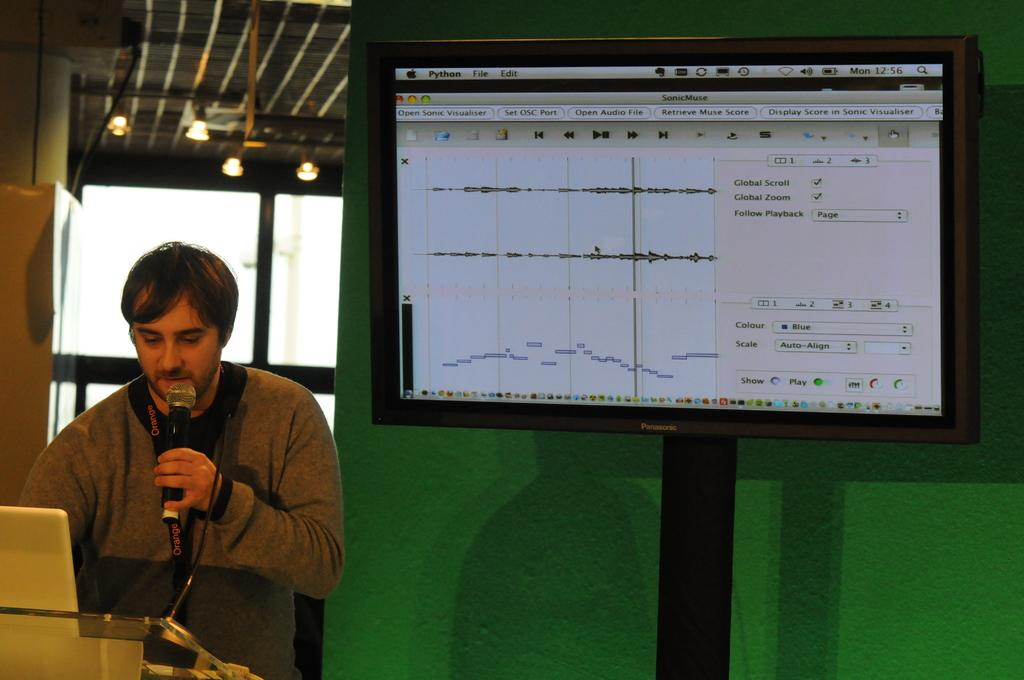Who is the person in the image? There is a man in the image. What is the man doing in the image? The man is speaking into a microphone. What can be seen on the television in the image? The television is displaying graphs. What type of lighting is visible in the image? There are lights visible at the top of the image. What type of eggnog is being served in the image? There is no eggnog present in the image. What is the man's afterthought after speaking into the microphone? The image does not provide information about the man's thoughts or feelings after speaking into the microphone. 